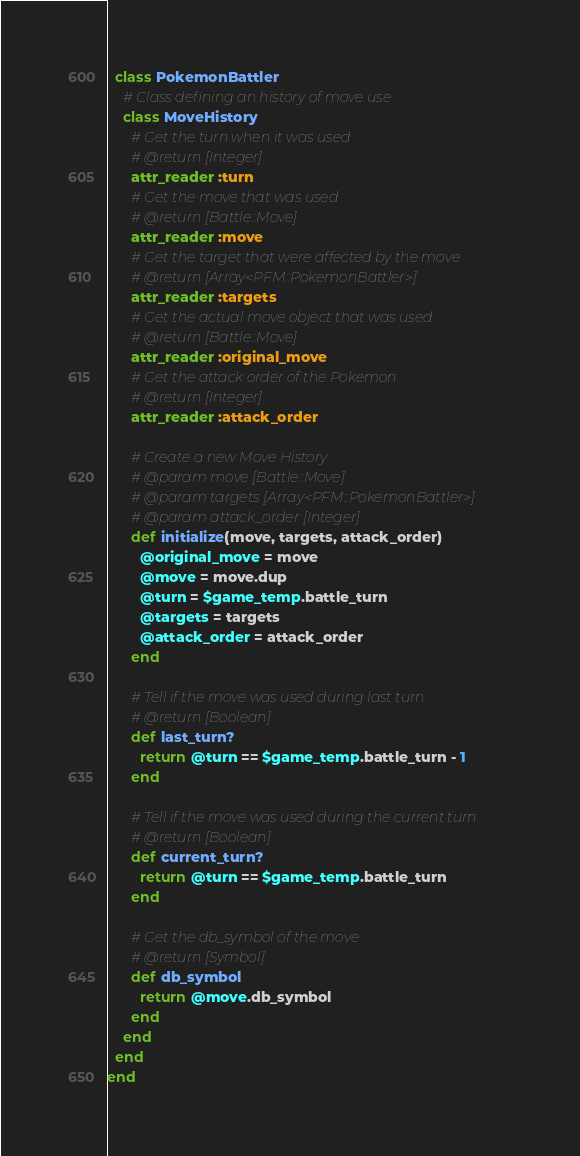Convert code to text. <code><loc_0><loc_0><loc_500><loc_500><_Ruby_>  class PokemonBattler
    # Class defining an history of move use
    class MoveHistory
      # Get the turn when it was used
      # @return [Integer]
      attr_reader :turn
      # Get the move that was used
      # @return [Battle::Move]
      attr_reader :move
      # Get the target that were affected by the move
      # @return [Array<PFM::PokemonBattler>]
      attr_reader :targets
      # Get the actual move object that was used
      # @return [Battle::Move]
      attr_reader :original_move
      # Get the attack order of the Pokemon
      # @return [Integer]
      attr_reader :attack_order

      # Create a new Move History
      # @param move [Battle::Move]
      # @param targets [Array<PFM::PokemonBattler>]
      # @param attack_order [Integer]
      def initialize(move, targets, attack_order)
        @original_move = move
        @move = move.dup
        @turn = $game_temp.battle_turn
        @targets = targets
        @attack_order = attack_order
      end

      # Tell if the move was used during last turn
      # @return [Boolean]
      def last_turn?
        return @turn == $game_temp.battle_turn - 1
      end

      # Tell if the move was used during the current turn
      # @return [Boolean]
      def current_turn?
        return @turn == $game_temp.battle_turn
      end

      # Get the db_symbol of the move
      # @return [Symbol]
      def db_symbol
        return @move.db_symbol
      end
    end
  end
end
</code> 